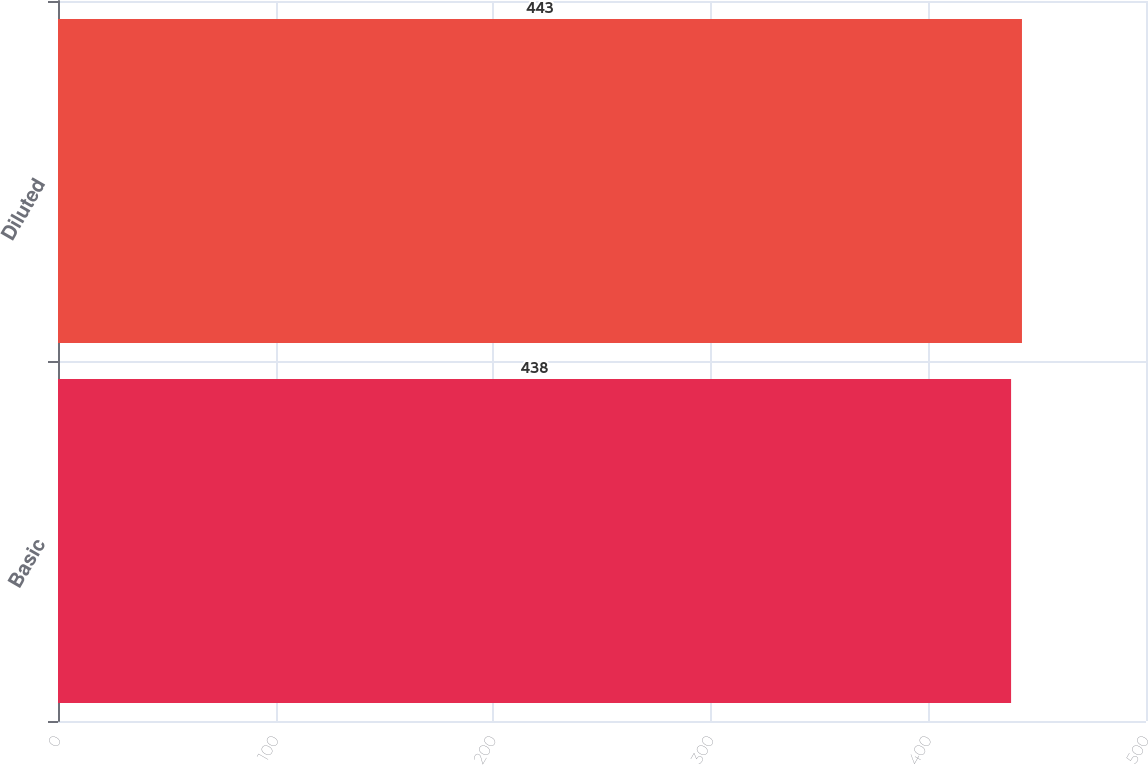Convert chart to OTSL. <chart><loc_0><loc_0><loc_500><loc_500><bar_chart><fcel>Basic<fcel>Diluted<nl><fcel>438<fcel>443<nl></chart> 